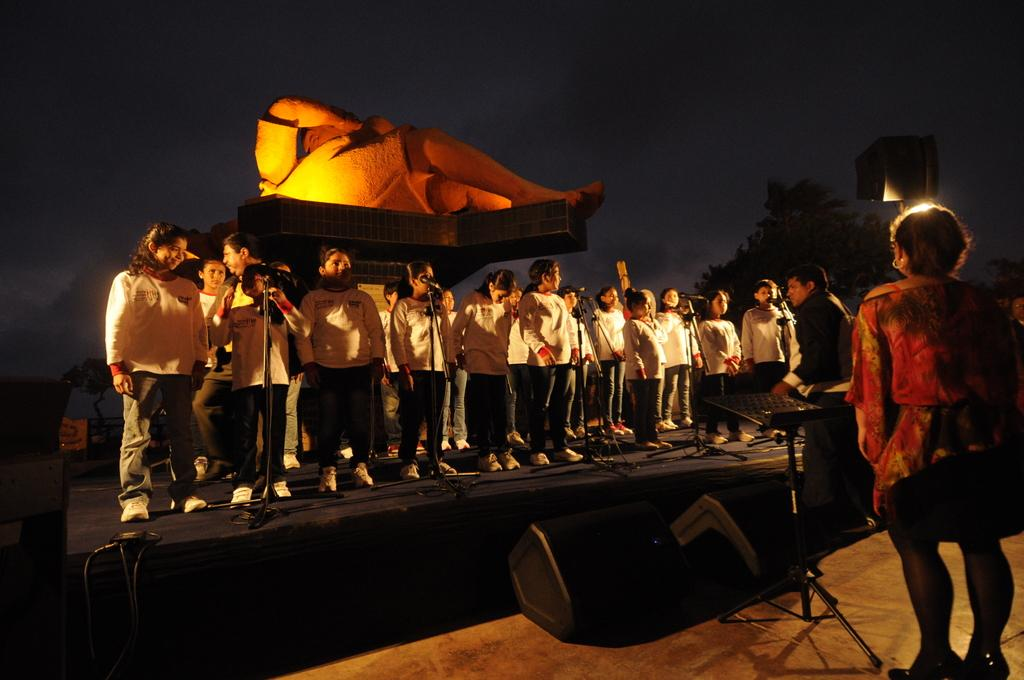What is happening on the stage in the image? There are people on the stage, which suggests some kind of performance or event is taking place. What equipment is visible on the stage? There are microphones and speakers on the stage, which are commonly used for amplifying sound during performances. Can you describe the statue on the stage? The statue is a decorative element on the stage, but its specific appearance or purpose cannot be determined from the image. How many people are present in the scene? There are two people in the scene, both of whom are on the stage. What is the stand used for in the scene? The stand is likely used to hold a microphone or other equipment, but its specific purpose cannot be determined from the image. What can be seen in the background of the image? There are trees and the sky visible in the background. What type of fiction is the statue holding in the image? There is no fiction present in the image, as the statue is an inanimate object and cannot hold or interact with fictional materials. 